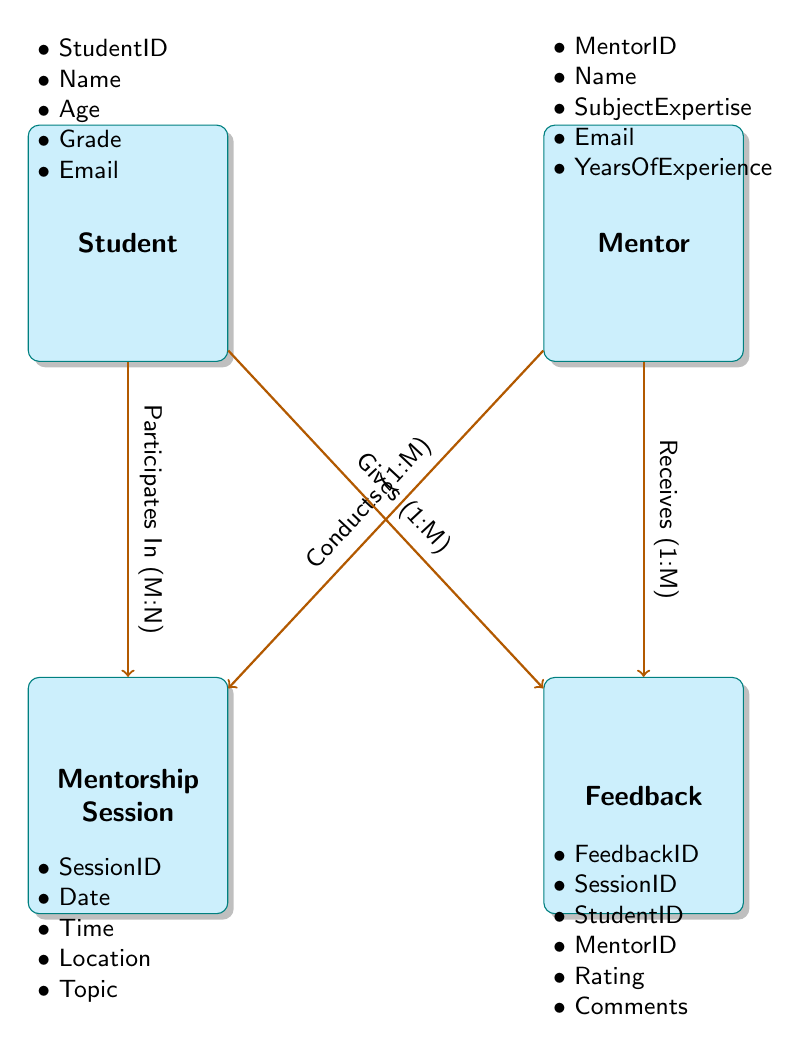What are the attributes of the Student entity? The Student entity has five attributes: StudentID, Name, Age, Grade, and Email. These can be found listed under the Student box in the diagram.
Answer: StudentID, Name, Age, Grade, Email How many entities are there in the diagram? The diagram shows four entities: Student, Mentor, Mentorship Session, and Feedback. By counting the entity boxes, we find the total number of entities.
Answer: 4 What is the relationship between the Mentor and Mentorship Session? The Mentor conducts the Mentorship Session, indicated by an arrow labeled 'Conducts' leading from the Mentor entity to the Mentorship Session entity, with cardinality 'One-to-Many' (1:M).
Answer: Conducts (1:M) What is the cardinality of the relationship between Student and Mentorship Session? The relationship 'Participates In' between Student and Mentorship Session shows that it is a Many-to-Many (M:N) relationship. This is indicated in the diagram where the arrow connecting these entities specifies this cardinality.
Answer: Many-to-Many (M:N) How many feedbacks can a single Student give? A single Student can give multiple feedbacks on different sessions, as indicated by the relationship 'Gives' labeled as 'One-to-Many' (1:M) from Student to Feedback. Therefore, there is no limit specified.
Answer: Many 